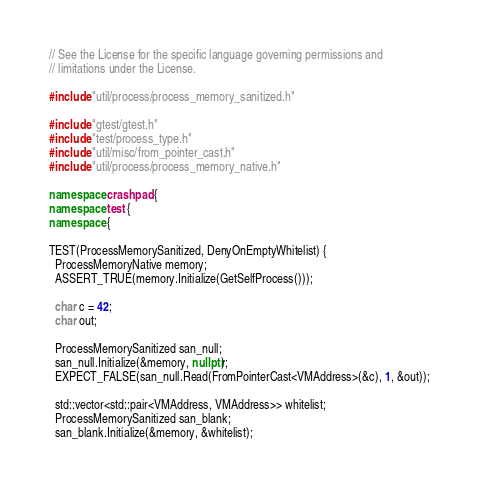<code> <loc_0><loc_0><loc_500><loc_500><_C++_>// See the License for the specific language governing permissions and
// limitations under the License.

#include "util/process/process_memory_sanitized.h"

#include "gtest/gtest.h"
#include "test/process_type.h"
#include "util/misc/from_pointer_cast.h"
#include "util/process/process_memory_native.h"

namespace crashpad {
namespace test {
namespace {

TEST(ProcessMemorySanitized, DenyOnEmptyWhitelist) {
  ProcessMemoryNative memory;
  ASSERT_TRUE(memory.Initialize(GetSelfProcess()));

  char c = 42;
  char out;

  ProcessMemorySanitized san_null;
  san_null.Initialize(&memory, nullptr);
  EXPECT_FALSE(san_null.Read(FromPointerCast<VMAddress>(&c), 1, &out));

  std::vector<std::pair<VMAddress, VMAddress>> whitelist;
  ProcessMemorySanitized san_blank;
  san_blank.Initialize(&memory, &whitelist);</code> 